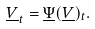<formula> <loc_0><loc_0><loc_500><loc_500>\underline { V } _ { t } = \underline { \Psi } ( \underline { V } ) _ { t } .</formula> 